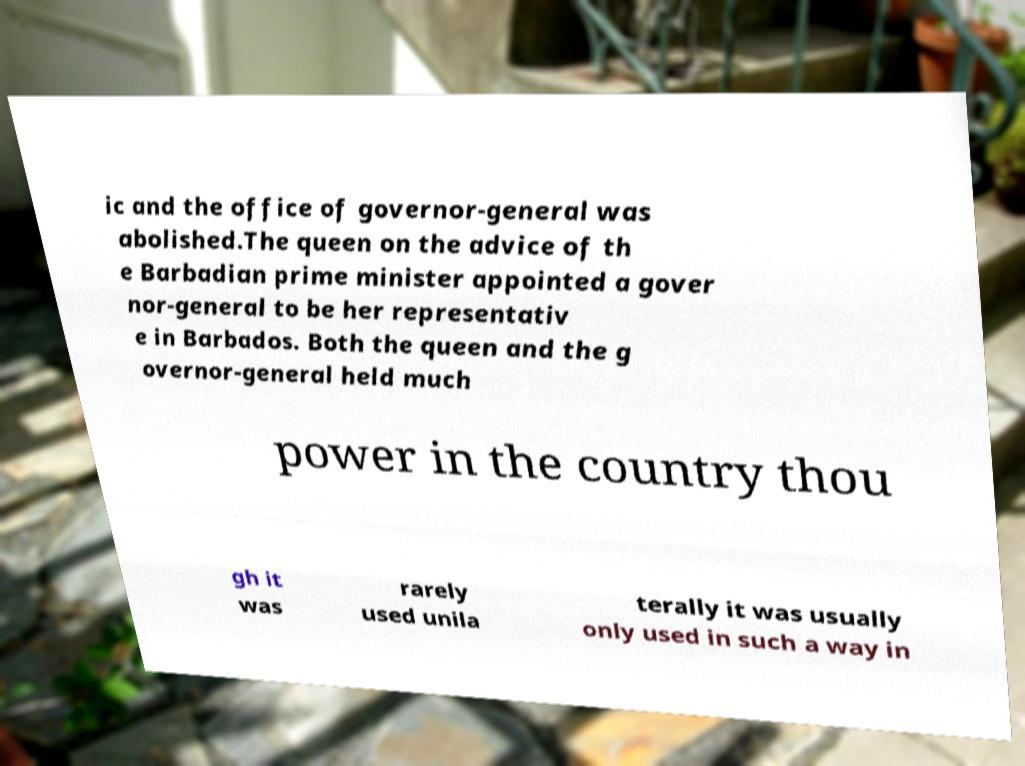Could you assist in decoding the text presented in this image and type it out clearly? ic and the office of governor-general was abolished.The queen on the advice of th e Barbadian prime minister appointed a gover nor-general to be her representativ e in Barbados. Both the queen and the g overnor-general held much power in the country thou gh it was rarely used unila terally it was usually only used in such a way in 